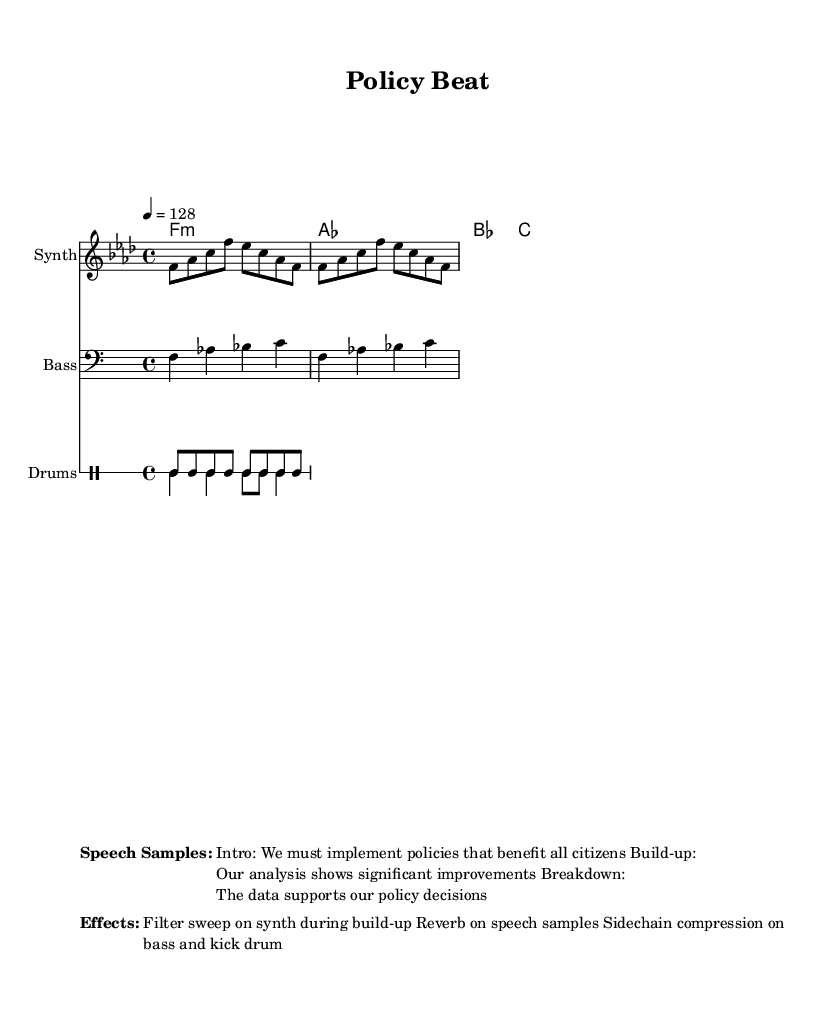What is the key signature of this music? The key signature is F minor, which has four flats (B♭, E♭, A♭, D♭). This is determined from the key indication at the beginning of the global context section.
Answer: F minor What is the time signature of this music? The time signature is 4/4, which means there are four beats in a measure. This is observed in the global context where the time signature is specified.
Answer: 4/4 What is the tempo marking for this piece? The tempo marking is 128 beats per minute, indicated by the tempo instruction in the global section of the score.
Answer: 128 How many speech samples are included in the markup? There are three speech samples listed: Intro, Build-up, and Breakdown. Each of these is introduced in the markup section under the "Speech Samples" heading.
Answer: 3 What type of instruments are included in the score? The instruments included in the score are Synth, Bass, and Drums. This can be found in the respective staffs labeled with these instrument names throughout the score.
Answer: Synth, Bass, Drums What specific effect is applied to the speech samples? Reverb is applied to the speech samples, as stated in the effects section of the markup. This indicates a treatment to enhance the spatial quality of the speech.
Answer: Reverb Which musical element is affected by sidechain compression? The sidechain compression affects both the bass and kick drum, as mentioned in the effects section. This technique is commonly used in house music to create a pumping effect.
Answer: Bass and kick drum 